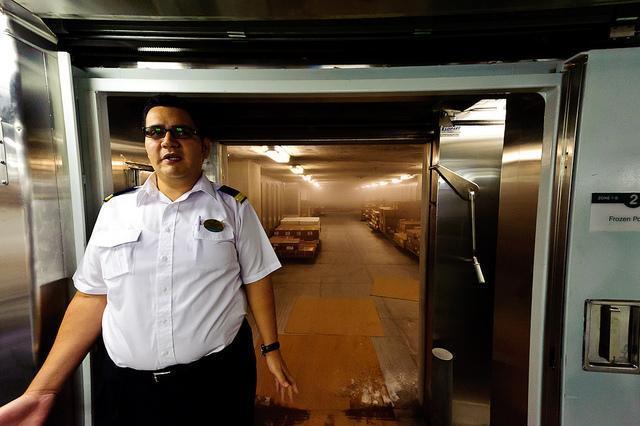How many people are in the foto?
Give a very brief answer. 1. 